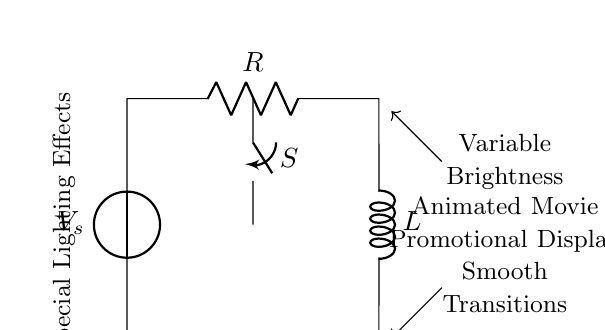What is the source voltage of the circuit? The voltage source labeled V_s in the circuit diagram represents the source voltage. The specific value is not given, but it is indicated as V_s.
Answer: V_s What type of switch is used in this circuit? The circuit includes a switch labeled S, which is a general type of switch that can open or close the circuit, allowing or interrupting the flow of current.
Answer: Switch What components are in this RL circuit? The circuit contains a resistor labeled R and an inductor labeled L. Together, these components form the basic elements of an RL circuit.
Answer: Resistor and Inductor What is the functional purpose of the inductor in this circuit? The inductor L is used to store energy in a magnetic field when current flows through it, which contributes to creating smooth transitions in the lighting effects.
Answer: Smooth transitions How does the resistor affect the current in this circuit? The resistor R limits the current flowing through the circuit according to Ohm's Law, affecting the overall brightness of the special lighting effects.
Answer: Limits current What lighting effect is achieved by this circuit? The circuit is designed for special lighting effects, specifically for providing variable brightness and smooth transitions suitable for the animated movie promotional display.
Answer: Special lighting effects 